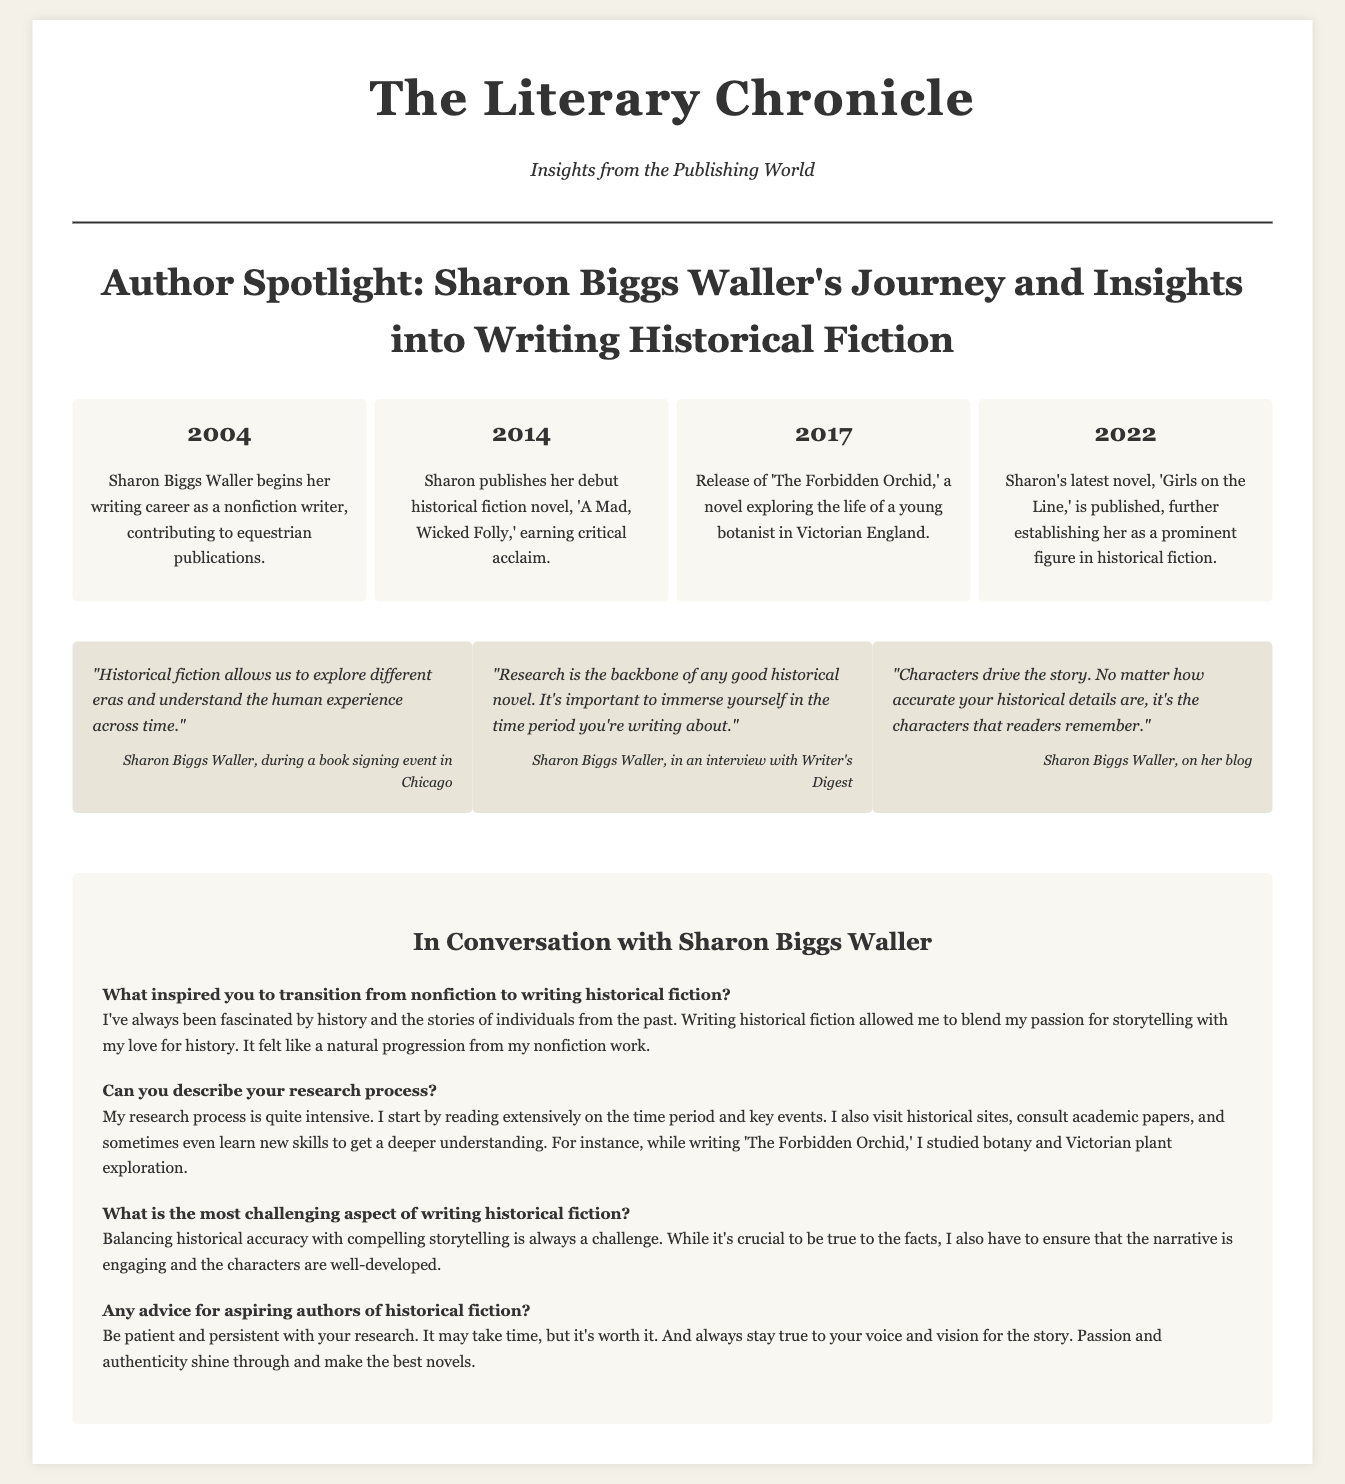What year did Sharon publish her debut novel? The debut novel 'A Mad, Wicked Folly' was published in 2014.
Answer: 2014 What is the title of Sharon's latest novel? The latest novel published by Sharon is 'Girls on the Line.'
Answer: Girls on the Line What does Sharon consider the backbone of a good historical novel? Sharon states that research is the backbone of any good historical novel.
Answer: Research How many novels has Sharon published by 2022? By 2022, Sharon has published three novels mentioned in the timeline.
Answer: Three What was Sharon's profession before writing historical fiction? Sharon began her career as a nonfiction writer.
Answer: Nonfiction writer What is a key challenge in writing historical fiction according to Sharon? Sharon indicates balancing historical accuracy with compelling storytelling is a challenge.
Answer: Balancing accuracy What needs to be true for a historical novel to be successful, according to Sharon? In Sharon's view, passion and authenticity make the best novels.
Answer: Passion and authenticity In what year did Sharon Waller begin her writing career? Sharon Biggs Waller started her writing career in 2004.
Answer: 2004 Where did Sharon make a statement about exploring different eras? Sharon made the statement during a book signing event in Chicago.
Answer: Book signing event in Chicago 